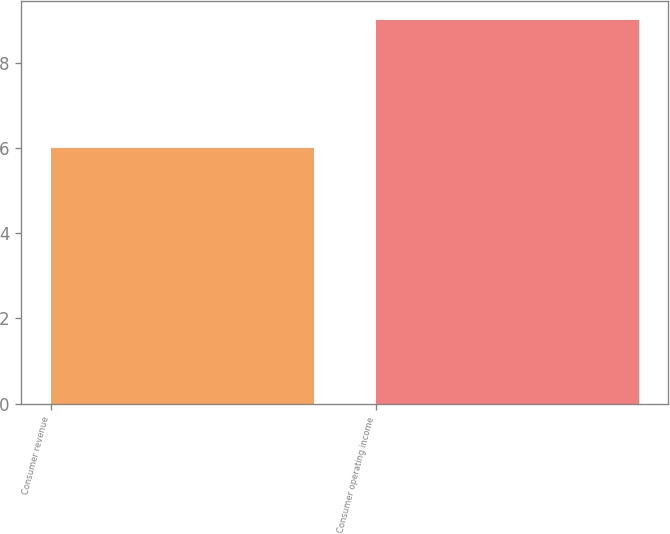<chart> <loc_0><loc_0><loc_500><loc_500><bar_chart><fcel>Consumer revenue<fcel>Consumer operating income<nl><fcel>6<fcel>9<nl></chart> 